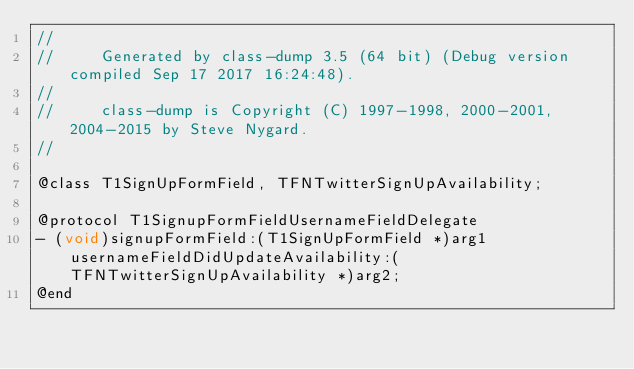Convert code to text. <code><loc_0><loc_0><loc_500><loc_500><_C_>//
//     Generated by class-dump 3.5 (64 bit) (Debug version compiled Sep 17 2017 16:24:48).
//
//     class-dump is Copyright (C) 1997-1998, 2000-2001, 2004-2015 by Steve Nygard.
//

@class T1SignUpFormField, TFNTwitterSignUpAvailability;

@protocol T1SignupFormFieldUsernameFieldDelegate
- (void)signupFormField:(T1SignUpFormField *)arg1 usernameFieldDidUpdateAvailability:(TFNTwitterSignUpAvailability *)arg2;
@end

</code> 